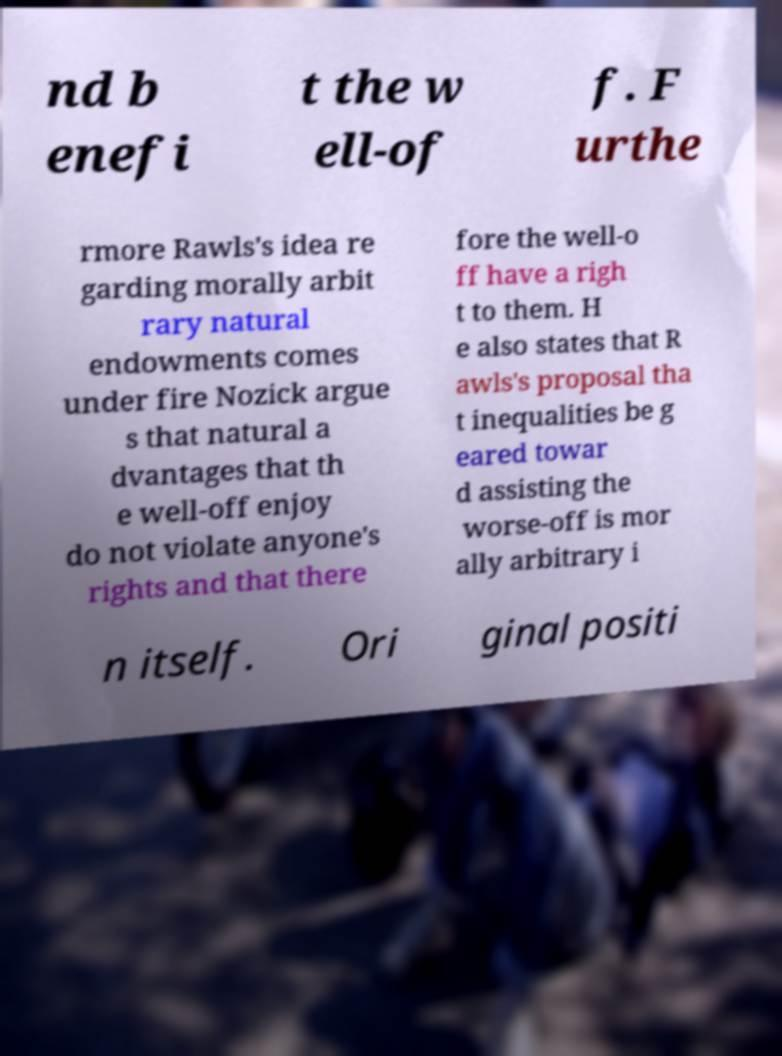Please identify and transcribe the text found in this image. nd b enefi t the w ell-of f. F urthe rmore Rawls's idea re garding morally arbit rary natural endowments comes under fire Nozick argue s that natural a dvantages that th e well-off enjoy do not violate anyone's rights and that there fore the well-o ff have a righ t to them. H e also states that R awls's proposal tha t inequalities be g eared towar d assisting the worse-off is mor ally arbitrary i n itself. Ori ginal positi 